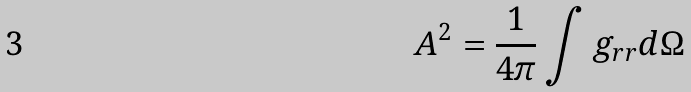<formula> <loc_0><loc_0><loc_500><loc_500>A ^ { 2 } = \frac { 1 } { 4 \pi } \int g _ { r r } d \Omega</formula> 